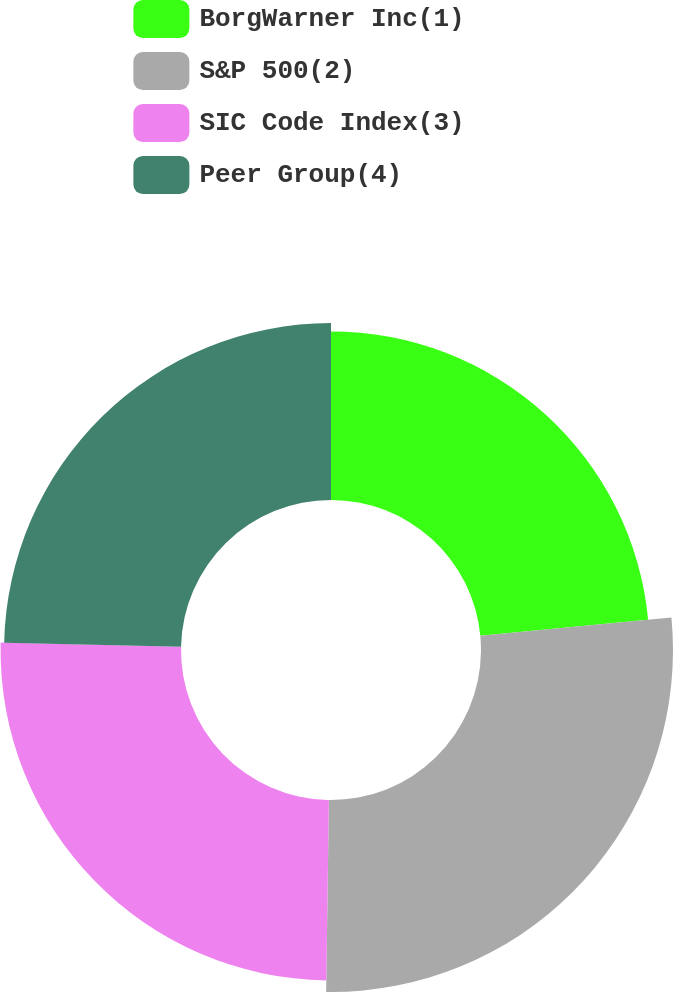<chart> <loc_0><loc_0><loc_500><loc_500><pie_chart><fcel>BorgWarner Inc(1)<fcel>S&P 500(2)<fcel>SIC Code Index(3)<fcel>Peer Group(4)<nl><fcel>23.48%<fcel>26.74%<fcel>25.13%<fcel>24.64%<nl></chart> 